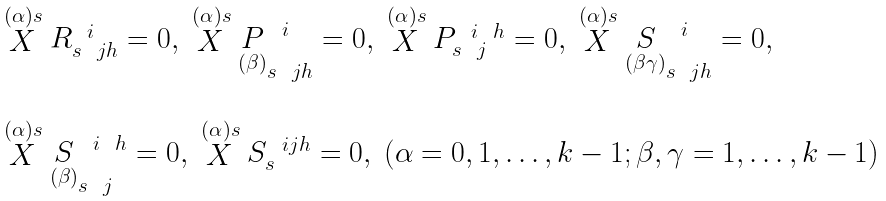Convert formula to latex. <formula><loc_0><loc_0><loc_500><loc_500>\begin{array} { l } \stackrel { ( \alpha ) s } { X } R _ { s \ \ j h } ^ { \ \ i } = 0 , \ \stackrel { ( \alpha ) s } { X } \underset { ( \beta ) } { P } _ { s \ \ j h } ^ { \ \ i } = 0 , \ \stackrel { ( \alpha ) s } { X } P _ { s \ \ j } ^ { \ \ i \ \ h } = 0 , \ \stackrel { ( \alpha ) s } { X } \underset { ( \beta \gamma ) } { S } _ { s \ \ j h } ^ { \ \ i } = 0 , \\ \\ \stackrel { ( \alpha ) s } { X } \underset { ( \beta ) } { S } _ { s \ \ j } ^ { \ \ i \ \ h } = 0 , \ \stackrel { ( \alpha ) s } { X } S _ { s } ^ { \ \ i j h } = 0 , \ ( \alpha = 0 , 1 , \dots , k - 1 ; \beta , \gamma = 1 , \dots , k - 1 ) \end{array}</formula> 